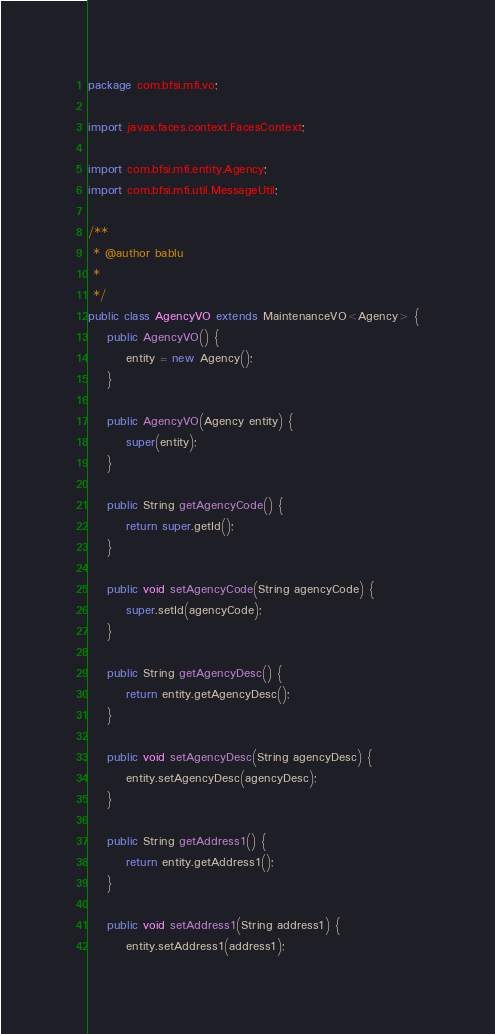<code> <loc_0><loc_0><loc_500><loc_500><_Java_>package com.bfsi.mfi.vo;

import javax.faces.context.FacesContext;

import com.bfsi.mfi.entity.Agency;
import com.bfsi.mfi.util.MessageUtil;

/**
 * @author bablu
 * 
 */
public class AgencyVO extends MaintenanceVO<Agency> {
	public AgencyVO() {
		entity = new Agency();
	}

	public AgencyVO(Agency entity) {
		super(entity);
	}

	public String getAgencyCode() {
		return super.getId();
	}

	public void setAgencyCode(String agencyCode) {
		super.setId(agencyCode);
	}

	public String getAgencyDesc() {
		return entity.getAgencyDesc();
	}

	public void setAgencyDesc(String agencyDesc) {
		entity.setAgencyDesc(agencyDesc);
	}

	public String getAddress1() {
		return entity.getAddress1();
	}

	public void setAddress1(String address1) {
		entity.setAddress1(address1);</code> 